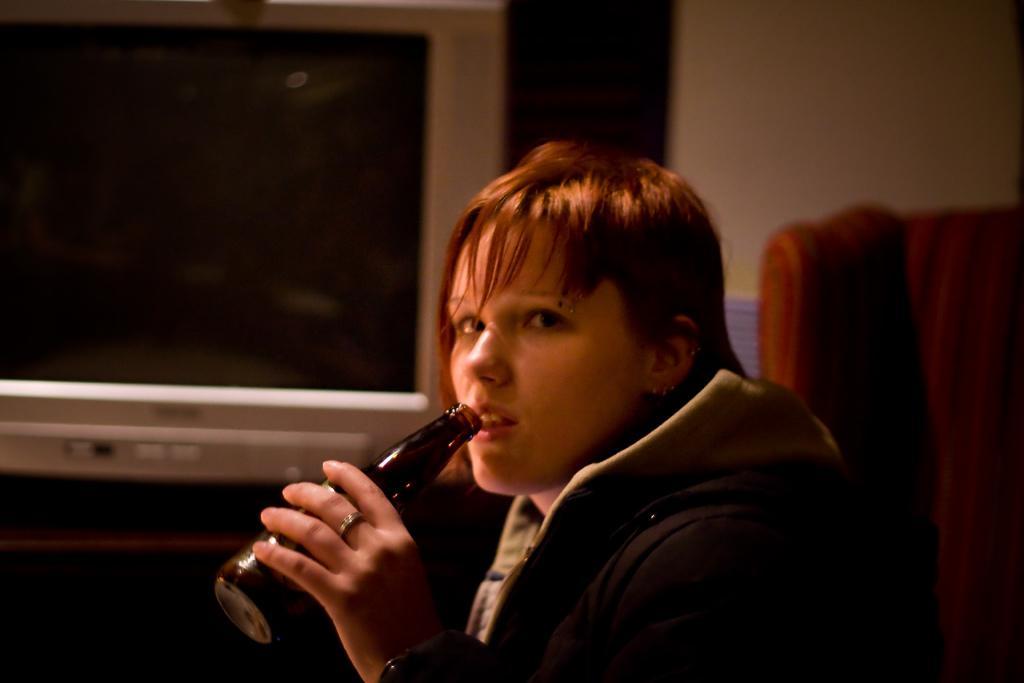Describe this image in one or two sentences. In this image we can see a woman. She is wearing a jacket and holding a bottle in her hand. In the background, we can see a television, table, wall and a chair. 